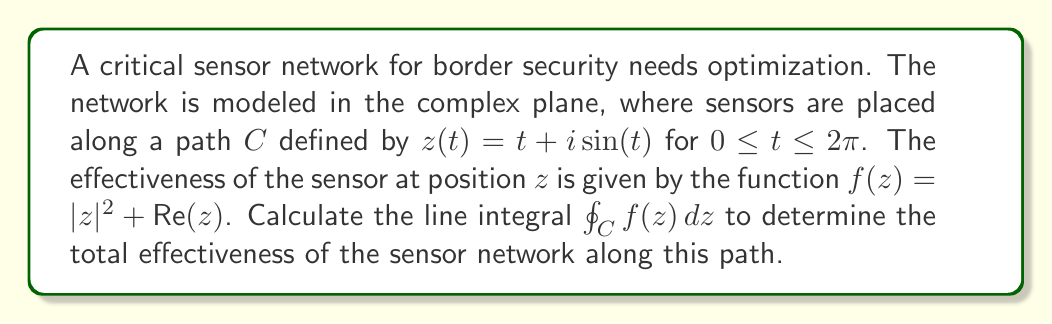What is the answer to this math problem? To evaluate this complex line integral, we'll follow these steps:

1) First, we need to parametrize the path $C$. We're given $z(t) = t + i\sin(t)$ for $0 \leq t \leq 2\pi$.

2) We need to find $dz$. Differentiating $z(t)$ with respect to $t$:
   $$\frac{dz}{dt} = 1 + i\cos(t)$$
   So, $dz = (1 + i\cos(t))dt$

3) Now, let's evaluate $f(z)$ along the path:
   $$f(z) = |z|^2 + \text{Re}(z) = (t + i\sin(t))(t - i\sin(t)) + t = t^2 + \sin^2(t) + t$$

4) The line integral is now:
   $$\oint_C f(z) dz = \int_0^{2\pi} (t^2 + \sin^2(t) + t)(1 + i\cos(t)) dt$$

5) Expanding this:
   $$\int_0^{2\pi} (t^2 + \sin^2(t) + t + it^2\cos(t) + i\sin^2(t)\cos(t) + it\cos(t)) dt$$

6) We can separate this into real and imaginary parts:
   Real part: $\int_0^{2\pi} (t^2 + \sin^2(t) + t) dt$
   Imaginary part: $\int_0^{2\pi} (t^2\cos(t) + \sin^2(t)\cos(t) + t\cos(t)) dt$

7) For the real part:
   $$\int_0^{2\pi} t^2 dt = \frac{t^3}{3}\bigg|_0^{2\pi} = \frac{8\pi^3}{3}$$
   $$\int_0^{2\pi} \sin^2(t) dt = \int_0^{2\pi} \frac{1-\cos(2t)}{2} dt = \pi$$
   $$\int_0^{2\pi} t dt = \frac{t^2}{2}\bigg|_0^{2\pi} = 2\pi^2$$

8) For the imaginary part:
   $$\int_0^{2\pi} t^2\cos(t) dt = 4\pi$$
   $$\int_0^{2\pi} \sin^2(t)\cos(t) dt = 0$$
   $$\int_0^{2\pi} t\cos(t) dt = -2\pi$$

9) Summing up the real and imaginary parts:
   Real part: $\frac{8\pi^3}{3} + \pi + 2\pi^2$
   Imaginary part: $4\pi - 2\pi = 2\pi$

Therefore, the final result is:
$$\frac{8\pi^3}{3} + \pi + 2\pi^2 + 2\pi i$$
Answer: $$\frac{8\pi^3}{3} + \pi + 2\pi^2 + 2\pi i$$ 